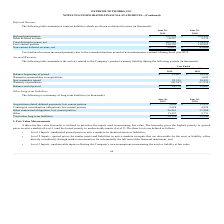From Extreme Networks's financial document, Which years does the table provide information for the Company’s product warranty liability? The document shows two values: 2019 and 2018. From the document: "2019 2018..." Also, What was the Balance beginning of period in 2018? According to the financial document, 10,584 (in thousands). The relevant text states: "Balance beginning of period $ 12,807 $ 10,584..." Also, What was the amount of new warranties issued in 2019? According to the financial document, 22,919 (in thousands). The relevant text states: "New warranties issued 22,919 10,491..." Also, How many years did the Balance beginning of period exceed $10,000 thousand? Counting the relevant items in the document: 2019, 2018, I find 2 instances. The key data points involved are: 2018, 2019. Also, can you calculate: What was the change in the Warranty expenditures between 2018 and 2019? Based on the calculation: -20,947-(-11,950), the result is -8997 (in thousands). This is based on the information: "Warranty expenditures (20,947) (11,950) Warranty expenditures (20,947) (11,950)..." The key data points involved are: 11,950, 20,947. Also, can you calculate: What was the percentage change in New warranties issued between 2018 and 2019? To answer this question, I need to perform calculations using the financial data. The calculation is: (22,919-10,491)/10,491, which equals 118.46 (percentage). This is based on the information: "New warranties issued 22,919 10,491 New warranties issued 22,919 10,491..." The key data points involved are: 10,491, 22,919. 